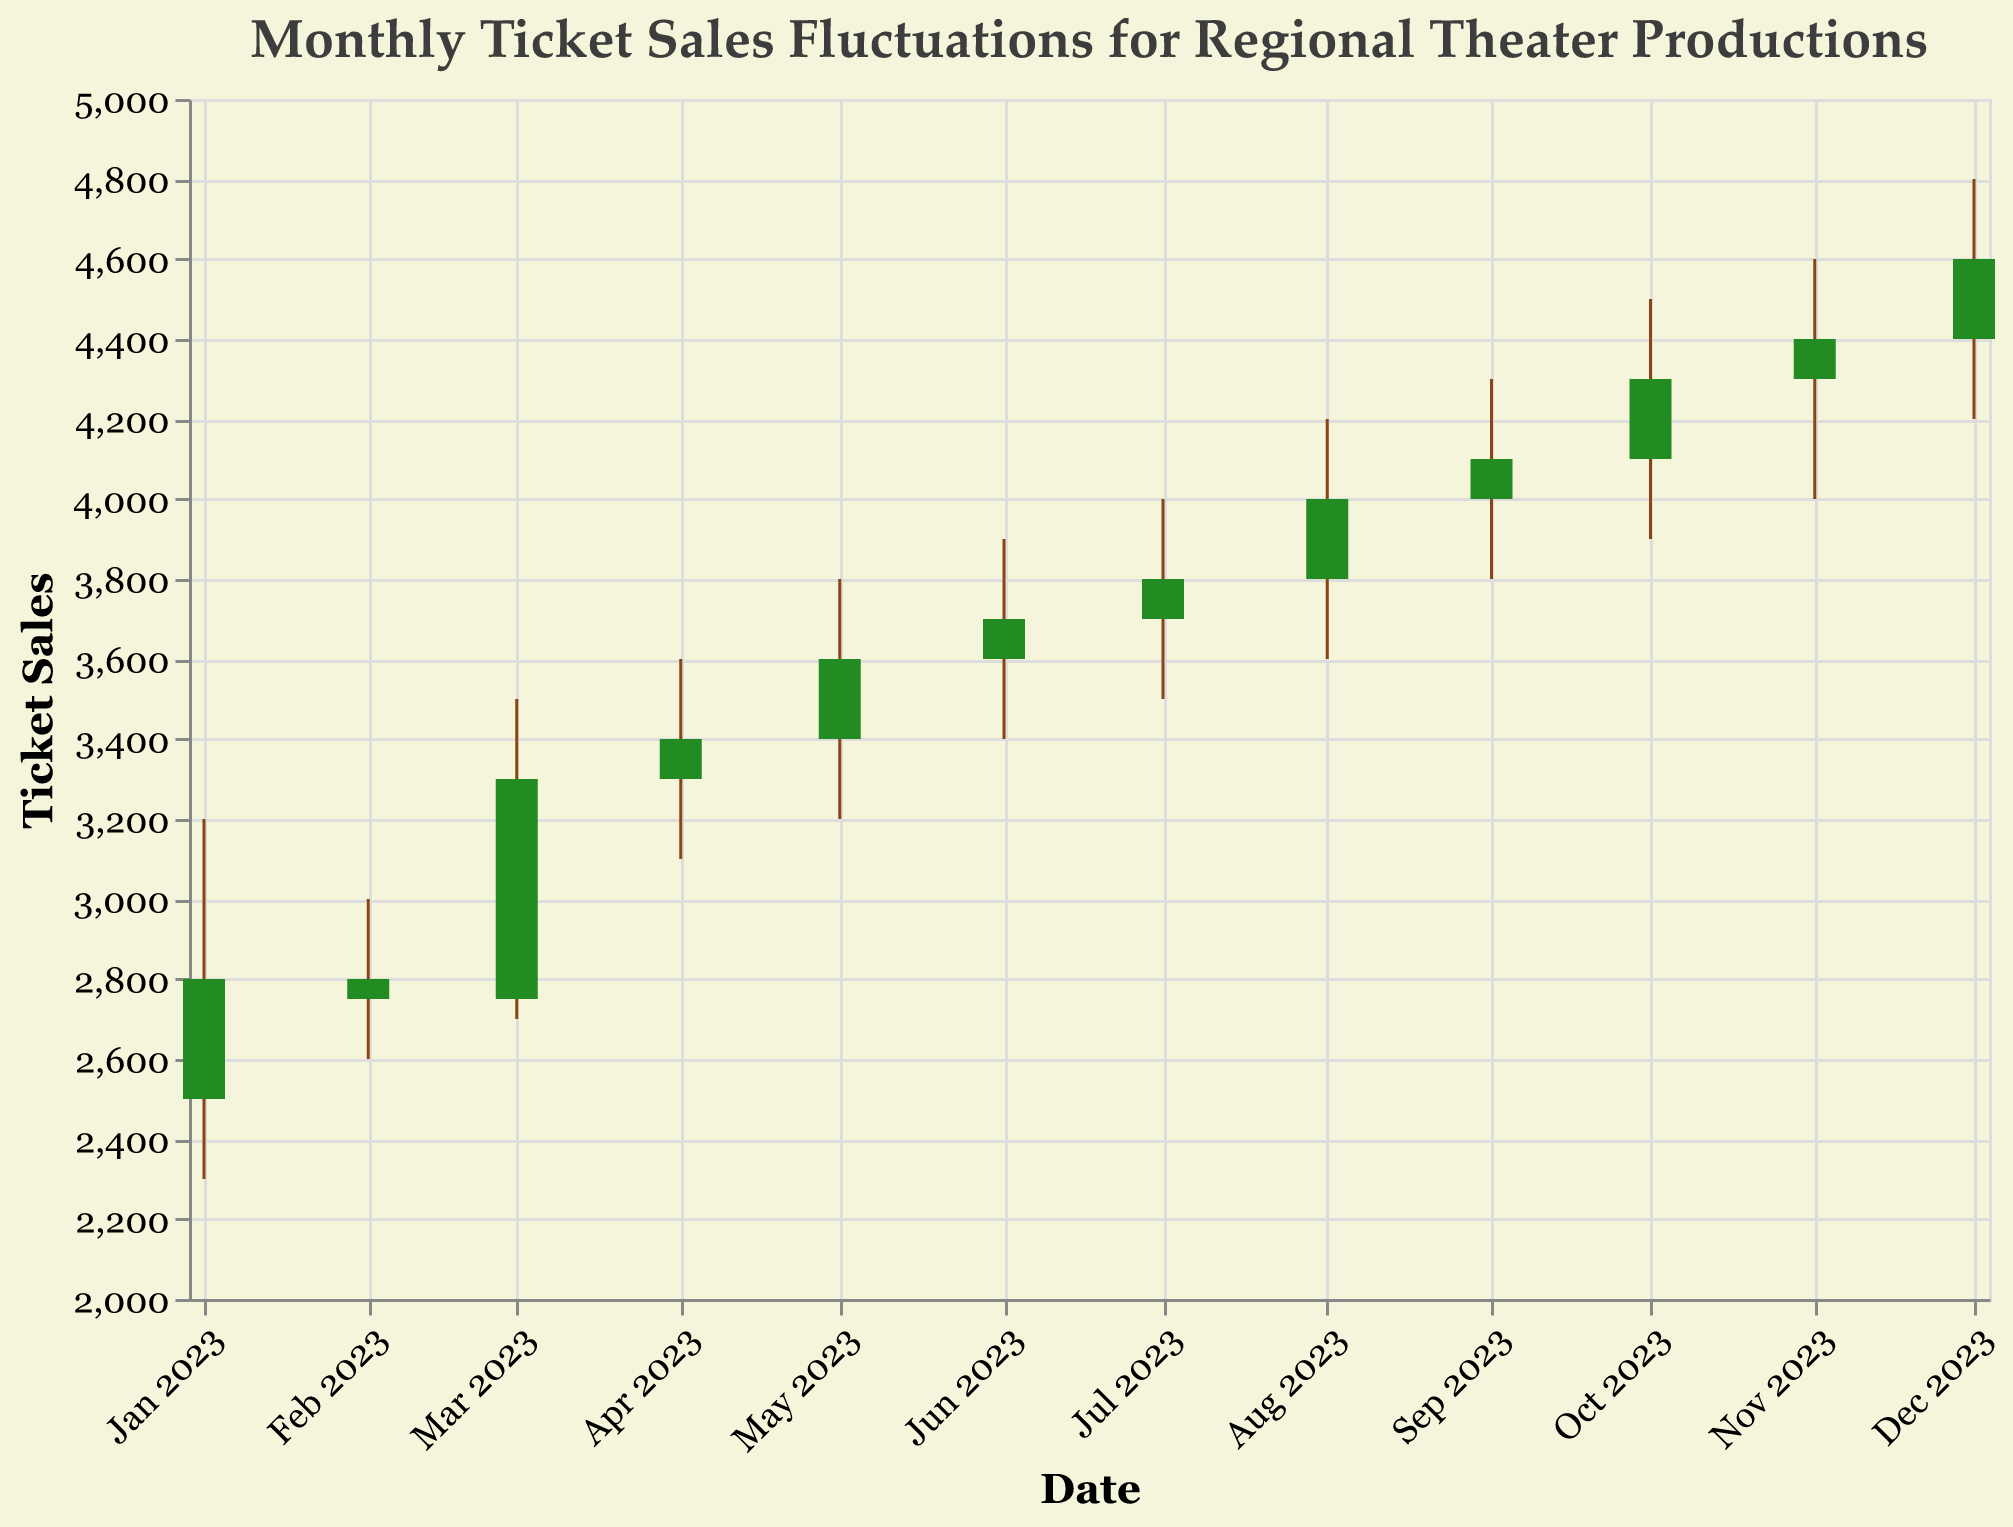What is the highest ticket sales value reached in December 2023? The High value for December 2023 is indicated on the OHLC chart. The maximum value of all recorded ticket sales in December 2023 is 4800.
Answer: 4800 What was the difference in ticket sales between the lowest point in January 2023 and the highest point in January 2023? The low value in January 2023 is 2300, and the high value is 3200. The difference is calculated by subtracting the lower value from the higher value: 3200 - 2300 = 900.
Answer: 900 During which month did ticket sales have the greatest fluctuation from low to high? To find the largest fluctuation, calculate (High - Low) for each month. The greatest fluctuation is in December 2023, where High is 4800 and Low is 4200. The fluctuation is 4800 - 4200 = 600.
Answer: December 2023 Which month experienced a decrease in ticket sales from the opening to the closing value? Checking each month where the open value is higher than the close value shows that February 2023 has an open of 2800 and a close of 2750, making it the correct month.
Answer: February 2023 How much did ticket sales increase from the opening to the closing value in August 2023? The open value for August 2023 is 3800, and the close value is 4000. The increase is calculated by subtracting the open value from the close value: 4000 - 3800 = 200.
Answer: 200 Which month had the highest closing value of ticket sales? The highest closing value can be identified visually in the OHLC chart, and it is 4600 in December 2023.
Answer: December 2023 What is the average high value of ticket sales across all months? Add the high values of all months (3200, 3000, 3500, 3600, 3800, 3900, 4000, 4200, 4300, 4500, 4600, 4800) and divide by the total number of months (12): (3200 + 3000 + 3500 + 3600 + 3800 + 3900 + 4000 + 4200 + 4300 + 4500 + 4600 + 4800) / 12 = 3842.
Answer: 3842 Were there months where the ticket sales closed at a higher value than the opening value? Checking each month shows that all months except February 2023 closed at a higher value than their opening value.
Answer: Yes How many months had a low value of ticket sales below 3000? Check the low values for each month to determine how many are below 3000. The months with lows below 3000 are January, February, and March (2300, 2600, 2700).
Answer: 3 